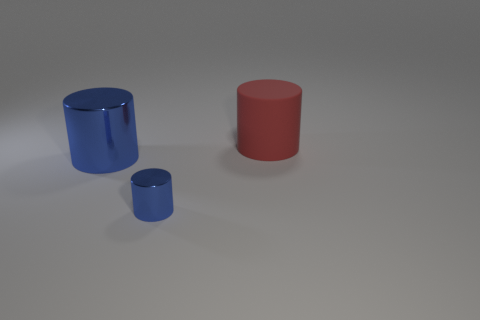Is there any other thing that has the same material as the red object?
Offer a very short reply. No. What is the color of the thing on the right side of the blue cylinder in front of the large metallic cylinder?
Ensure brevity in your answer.  Red. There is a cylinder that is both on the left side of the big red rubber thing and behind the small metal cylinder; what is its material?
Offer a very short reply. Metal. Are there any small shiny things of the same shape as the big metal thing?
Your response must be concise. Yes. There is a thing that is in front of the large blue thing; does it have the same shape as the big red thing?
Make the answer very short. Yes. What number of cylinders are both right of the small blue cylinder and on the left side of the small blue metal object?
Offer a very short reply. 0. The big object that is in front of the rubber thing has what shape?
Make the answer very short. Cylinder. How many blue objects have the same material as the big red object?
Make the answer very short. 0. There is a large red matte object; does it have the same shape as the blue object to the left of the small blue cylinder?
Keep it short and to the point. Yes. There is a shiny cylinder that is in front of the large cylinder in front of the big red thing; are there any metal things that are to the left of it?
Provide a succinct answer. Yes. 